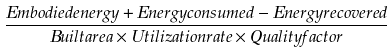Convert formula to latex. <formula><loc_0><loc_0><loc_500><loc_500>\frac { { E m b o d i e d e n e r g y } + { E n e r g y c o n s u m e d } - { E n e r g y r e c o v e r e d } } { { B u i l t a r e a } \times { U t i l i z a t i o n r a t e } \times { Q u a l i t y f a c t o r } }</formula> 